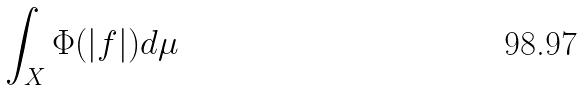Convert formula to latex. <formula><loc_0><loc_0><loc_500><loc_500>\int _ { X } \Phi ( | f | ) d \mu</formula> 